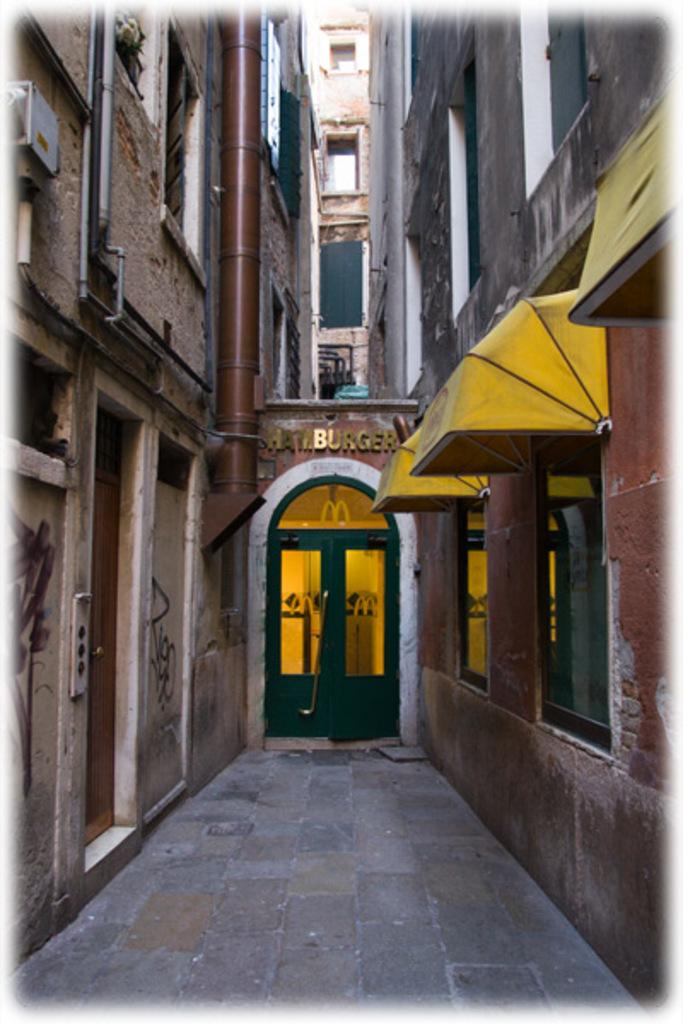What type of structure is visible in the image? There is a building in the image. What is one feature of the building that can be seen? There is a door in the image. Are there any openings in the building that allow light and air to enter? Yes, there are windows in the image. Can you see any fairies flying around the building in the image? No, there are no fairies present in the image. What type of impulse can be seen affecting the building in the image? There is no impulse affecting the building in the image; it is a static structure. 